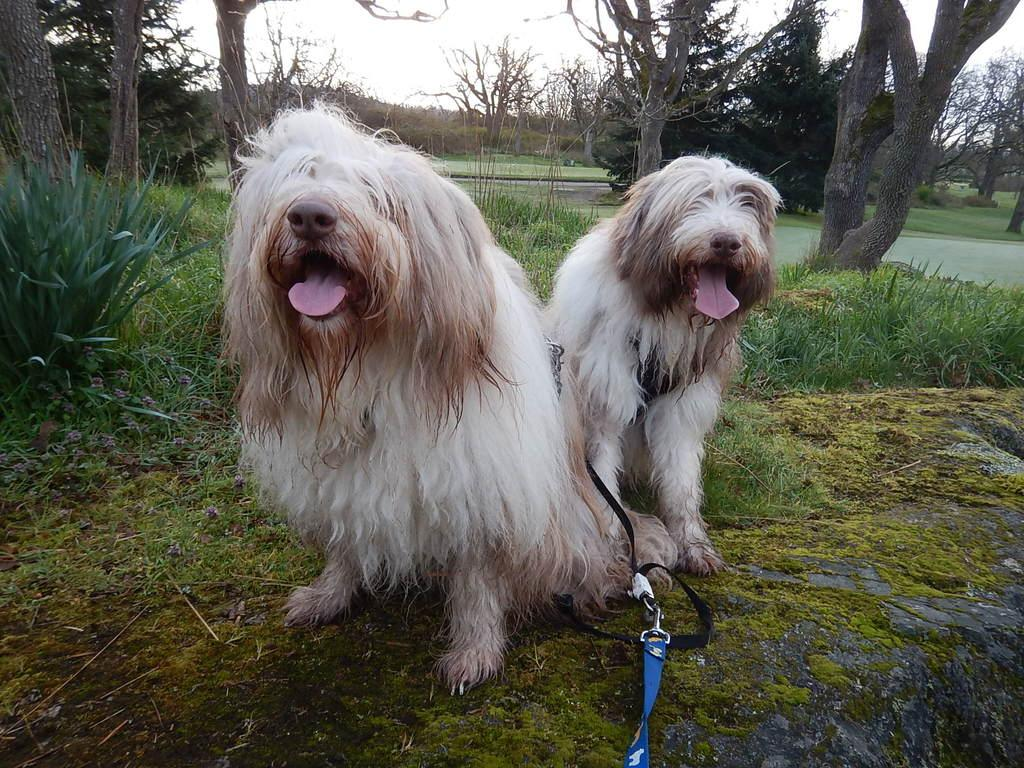How many dogs are in the image? There are two dogs in the image. What are the colors of the dogs? One dog is white and the other is brown. Are the dogs wearing any accessories in the image? Yes, the dogs have leashes. What can be seen in the background of the image? There are trees and a clear sky in the background of the image. What type of carpenter tools can be seen in the image? There are no carpenter tools present in the image. What attraction is visible in the background of the image? There is no attraction visible in the image; only trees and a clear sky are present in the background. 